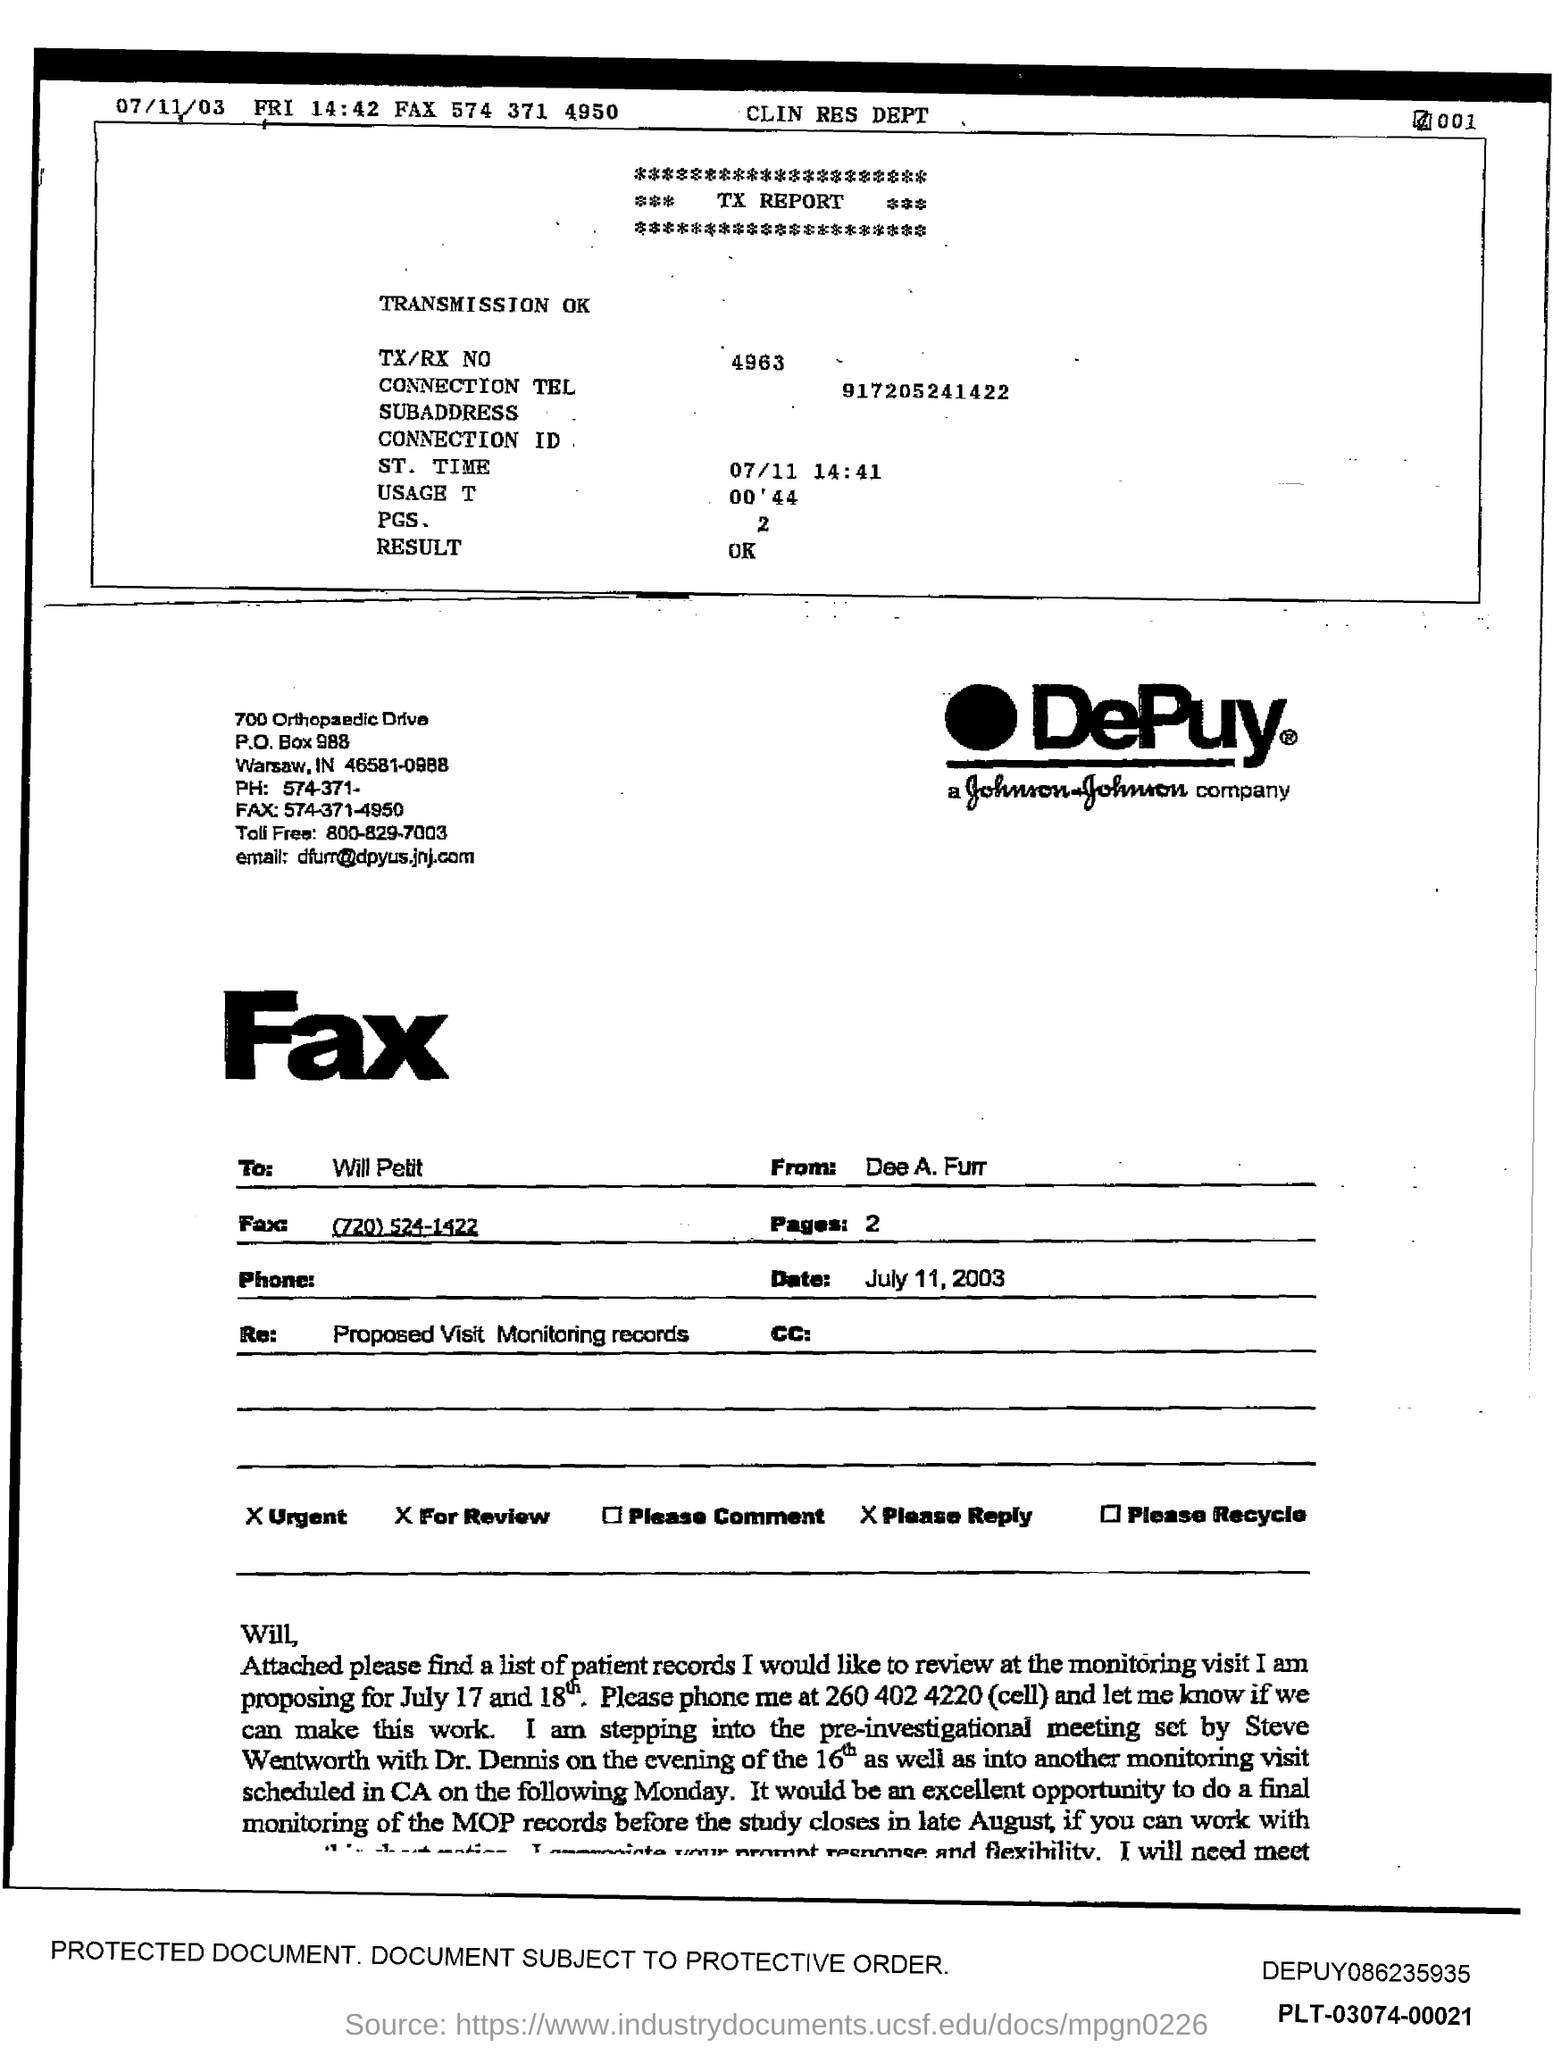What is the PO Box Number mentioned in the document?
Give a very brief answer. 988. What is the toll free number?
Provide a succinct answer. 800-829-7003. What is the Email id?
Your answer should be very brief. Dfurr@dpyus.jnj.com. What is the TX/RX Number?
Make the answer very short. 4963. 